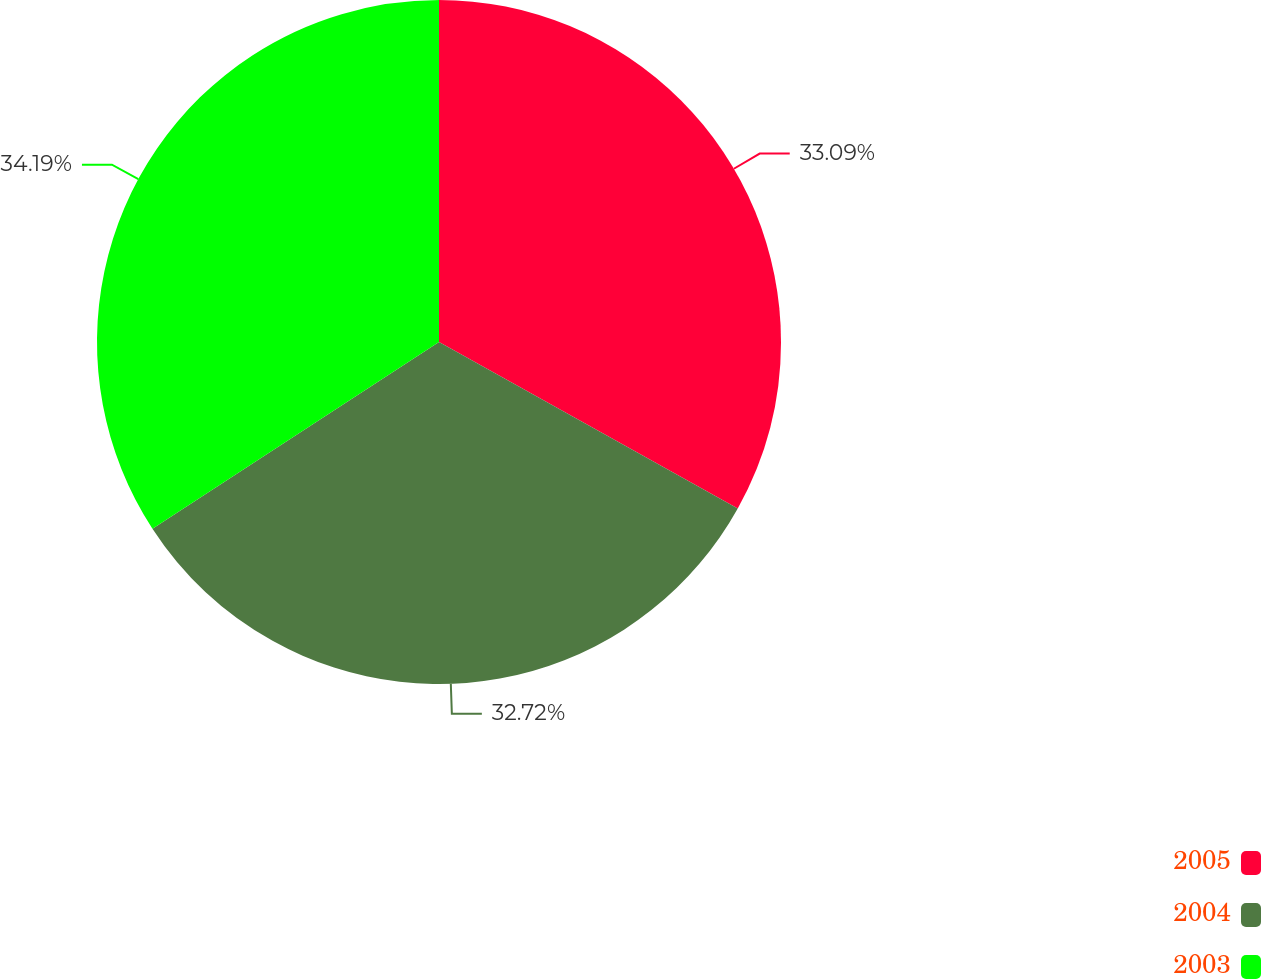<chart> <loc_0><loc_0><loc_500><loc_500><pie_chart><fcel>2005<fcel>2004<fcel>2003<nl><fcel>33.09%<fcel>32.72%<fcel>34.19%<nl></chart> 